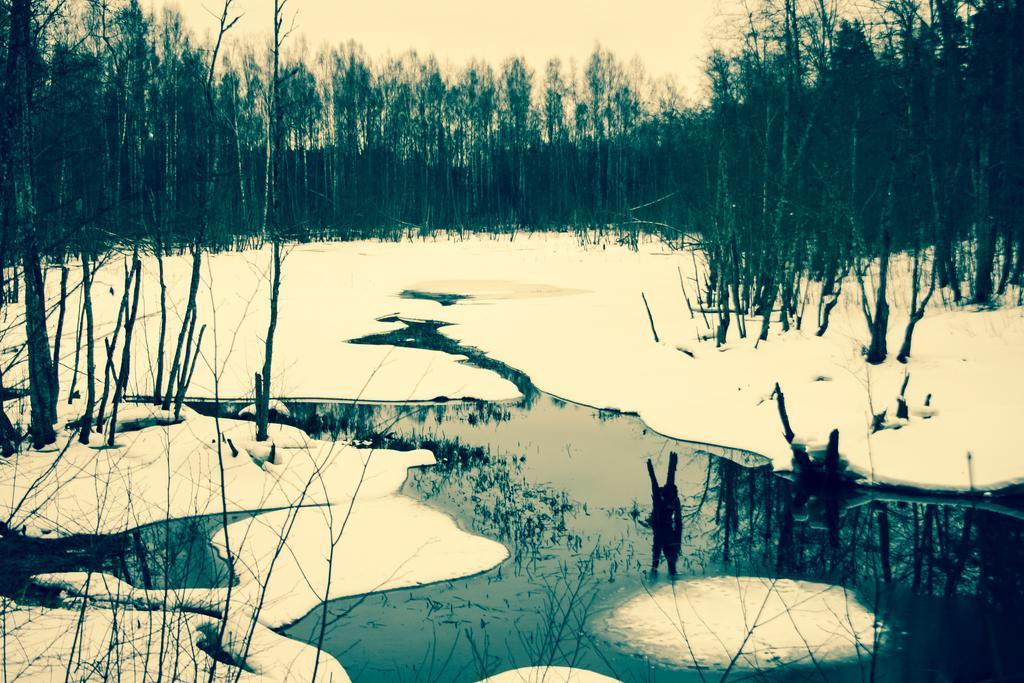Describe this image in one or two sentences. In this image I can see the snow and the water on the ground. I can see few trees and in the background I can see the sky. 